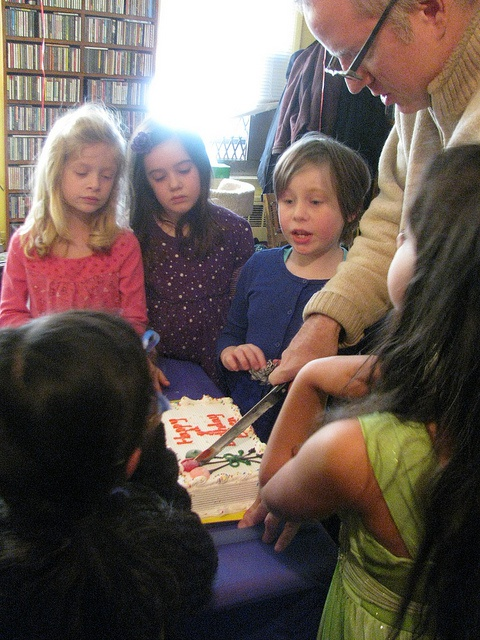Describe the objects in this image and their specific colors. I can see people in lightyellow, black, darkgreen, maroon, and gray tones, people in lightyellow, black, gray, and maroon tones, people in lightyellow, brown, tan, and gray tones, dining table in lightyellow, black, navy, purple, and beige tones, and people in lightyellow, black, navy, gray, and purple tones in this image. 